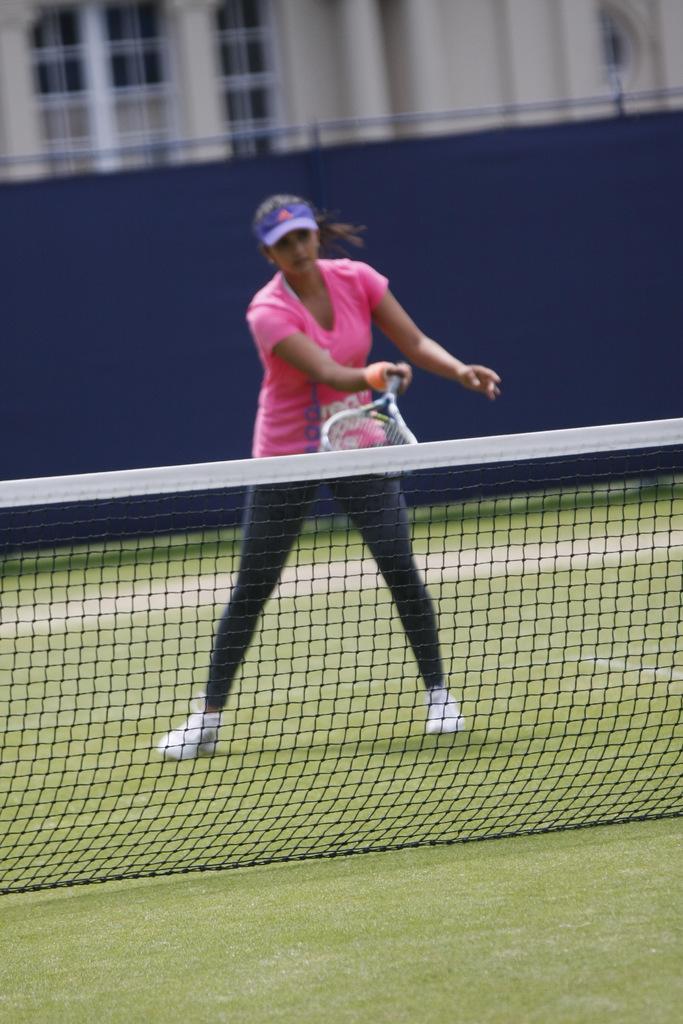How would you summarize this image in a sentence or two? The image is inside the playground. In the image we can see a woman holding a tennis racket and we can also see a net fence. In background there is a building which is in white color and a blue color curtain. 